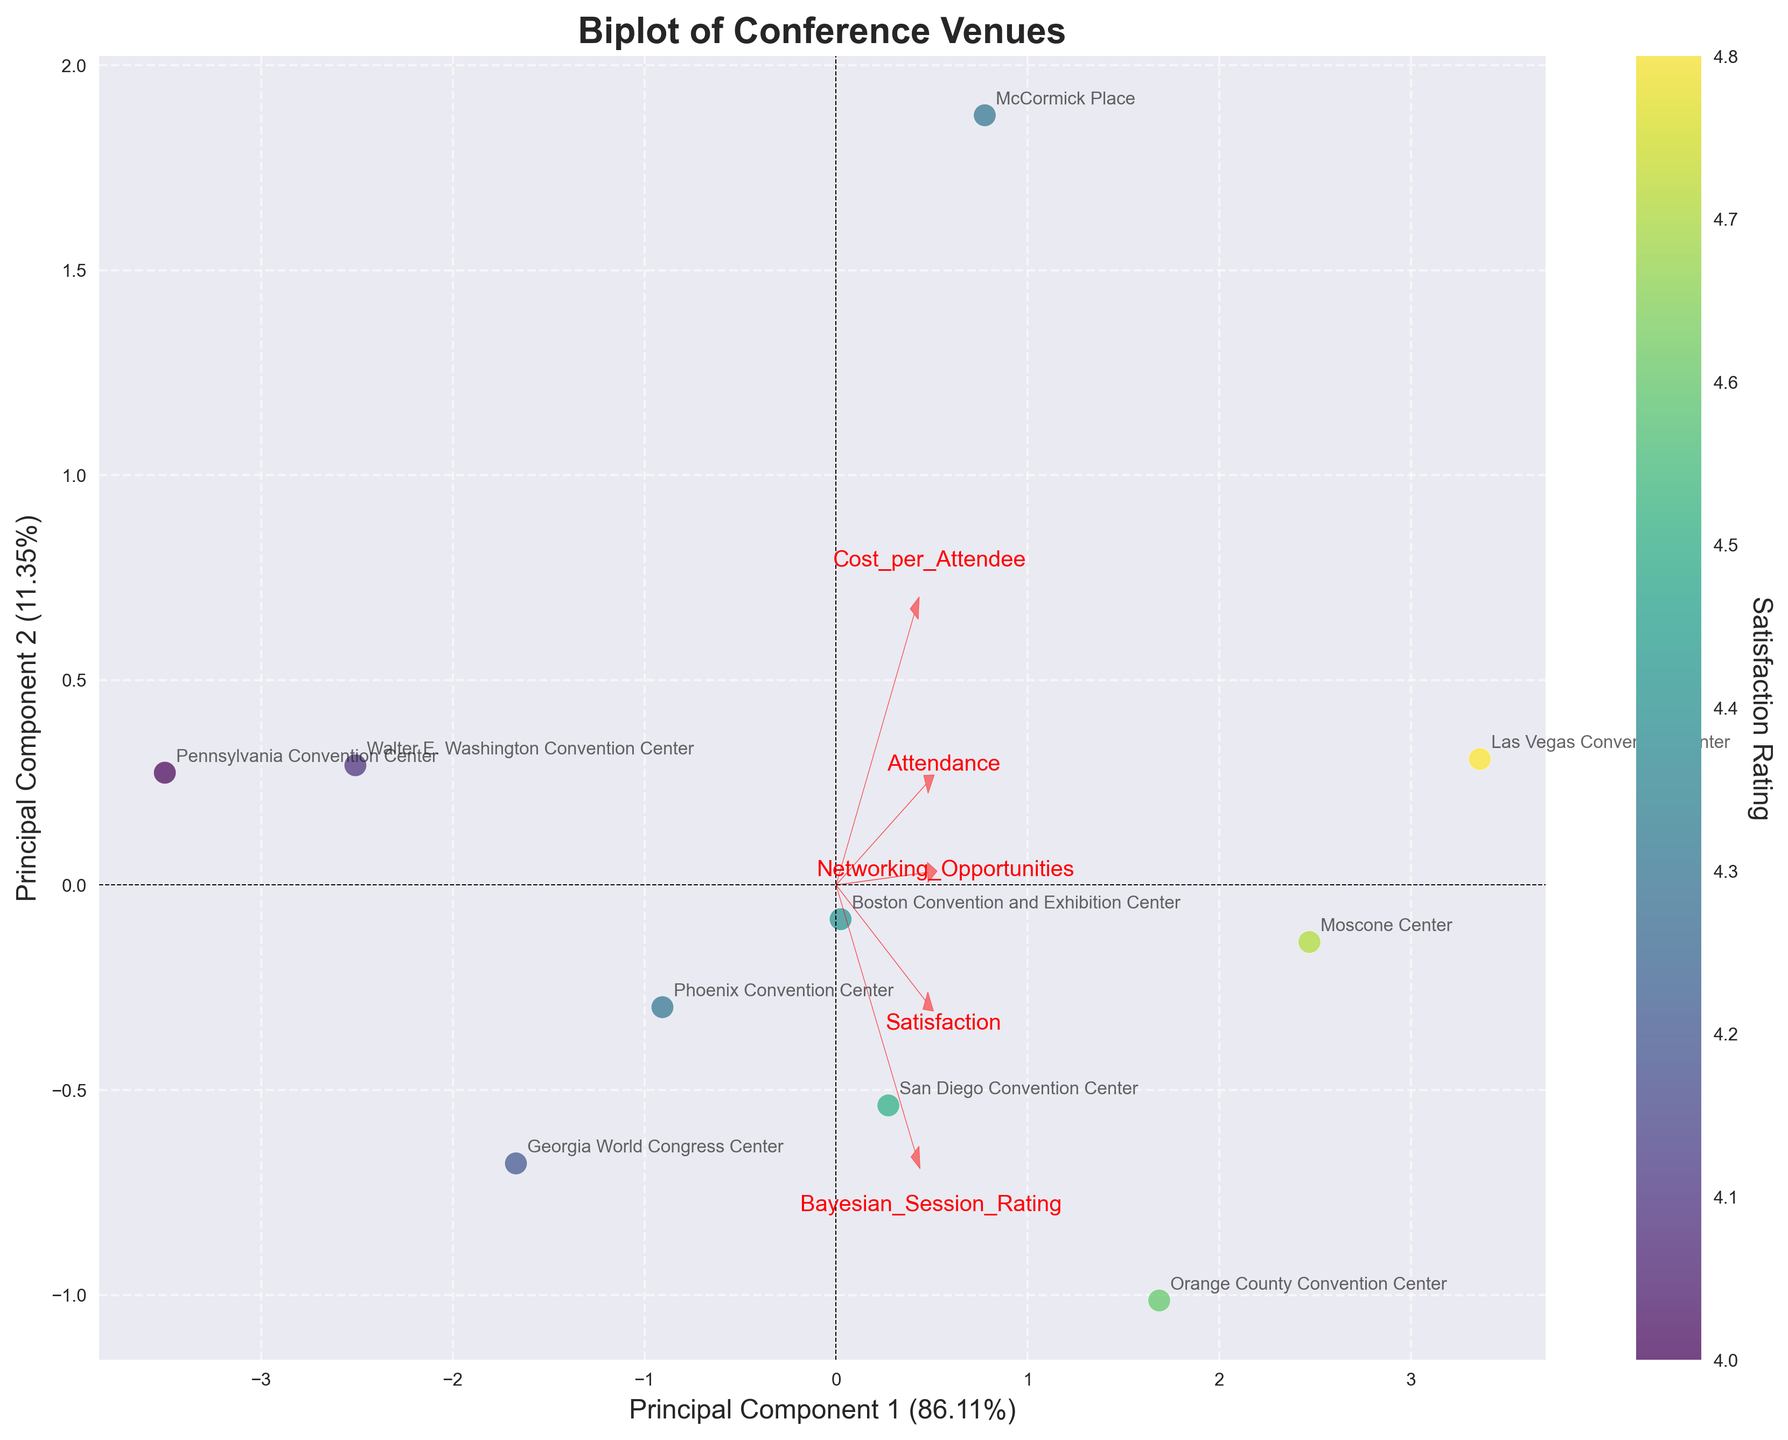How many venues are plotted in the biplot? Count the number of unique data points annotated with venue names in the biplot. There are 10 unique venues listed in the data.
Answer: 10 What is the range of the first principal component? Look at the minimum and maximum values along the x-axis (Principal Component 1). The range extends from approximately -2.5 to 2.5 based on the data distribution in the figure.
Answer: -2.5 to 2.5 Which venue has the highest satisfaction rating? Check the color scale and find the data point with the highest satisfaction rating (darkest color). According to the data, Las Vegas Convention Center has the highest satisfaction rating of 4.8.
Answer: Las Vegas Convention Center Are satisfaction ratings positively or negatively correlated with Bayesian Session Rating in this biplot? Observe the direction of the feature vectors for Satisfaction and Bayesian Session Rating relative to each other. Both vectors point in similar directions indicating a positive correlation.
Answer: Positively correlated Which features seem to contribute the most to the first principal component? Look at the length and direction of the feature vectors relative to Principal Component 1. Attendance and Cost per Attendee vectors are the longest and most aligned with Principal Component 1.
Answer: Attendance and Cost per Attendee Which venue has the lowest networking opportunities rating? Identify the data point with the lowest positioning along the vector for Networking Opportunities. Pennsylvania Convention Center has the lowest rating based on data annotations.
Answer: Pennsylvania Convention Center What is the explained variance of the first principal component? Refer to the labeled x-axis of the biplot, which indicates the percentage of variance explained by Principal Component 1. It is stated as 40%.
Answer: 40% Among Moscone Center and McCormick Place, which has higher attendance? Find the locations for Moscone Center and McCormick Place on the biplot and compare their positions along the Attendance vector. The Moscone Center has a higher Attendance rating.
Answer: Moscone Center How are cost per attendee and satisfaction rating correlated? Observe the directions of the vectors for Cost per Attendee and Satisfaction Rating. The vectors are pointed in roughly opposite directions, indicating a negative correlation.
Answer: Negatively correlated 